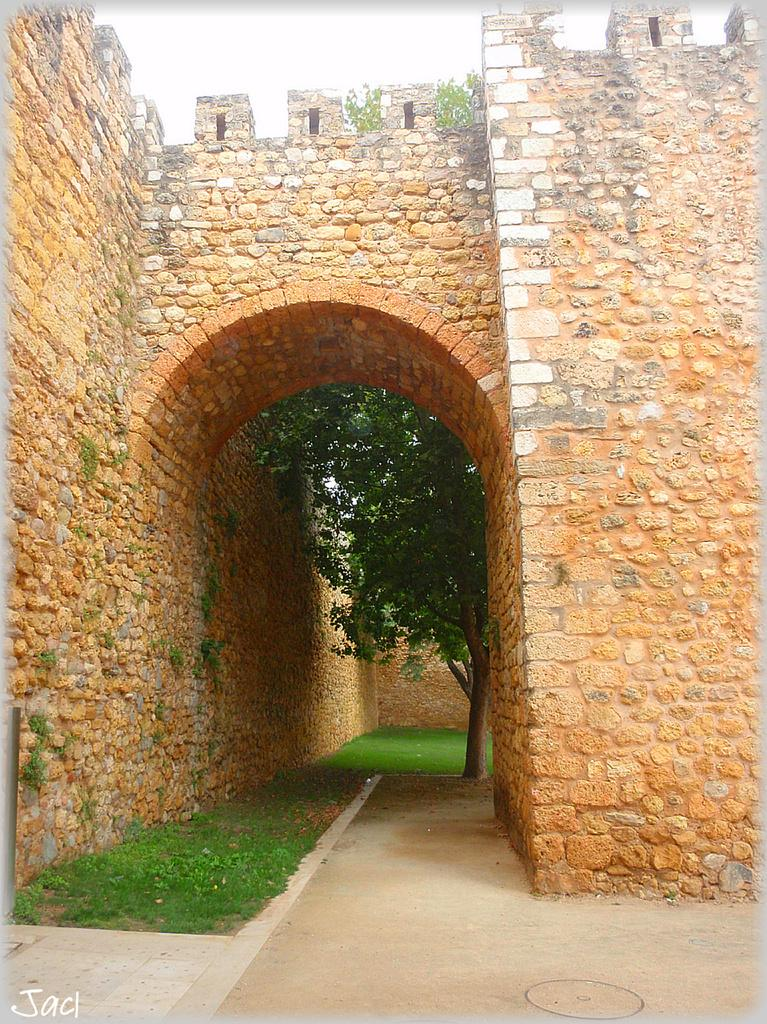What type of structure is present in the image? There is a stone arch in the image. What type of vegetation can be seen in the image? There is grass in the image. What other stone structure is visible in the image? There is a stone wall in the image. What can be seen in the background of the image? There are trees and the sky visible in the background of the image. Is there any text or logo present in the image? Yes, there is a watermark in the image. What type of game is being played on the stone wall in the image? There is no game being played in the image; it only features a stone arch, grass, a stone wall, trees, the sky, and a watermark. Can you describe the coil that is wrapped around the trees in the background? There is no coil present in the image; the trees are simply visible in the background. 